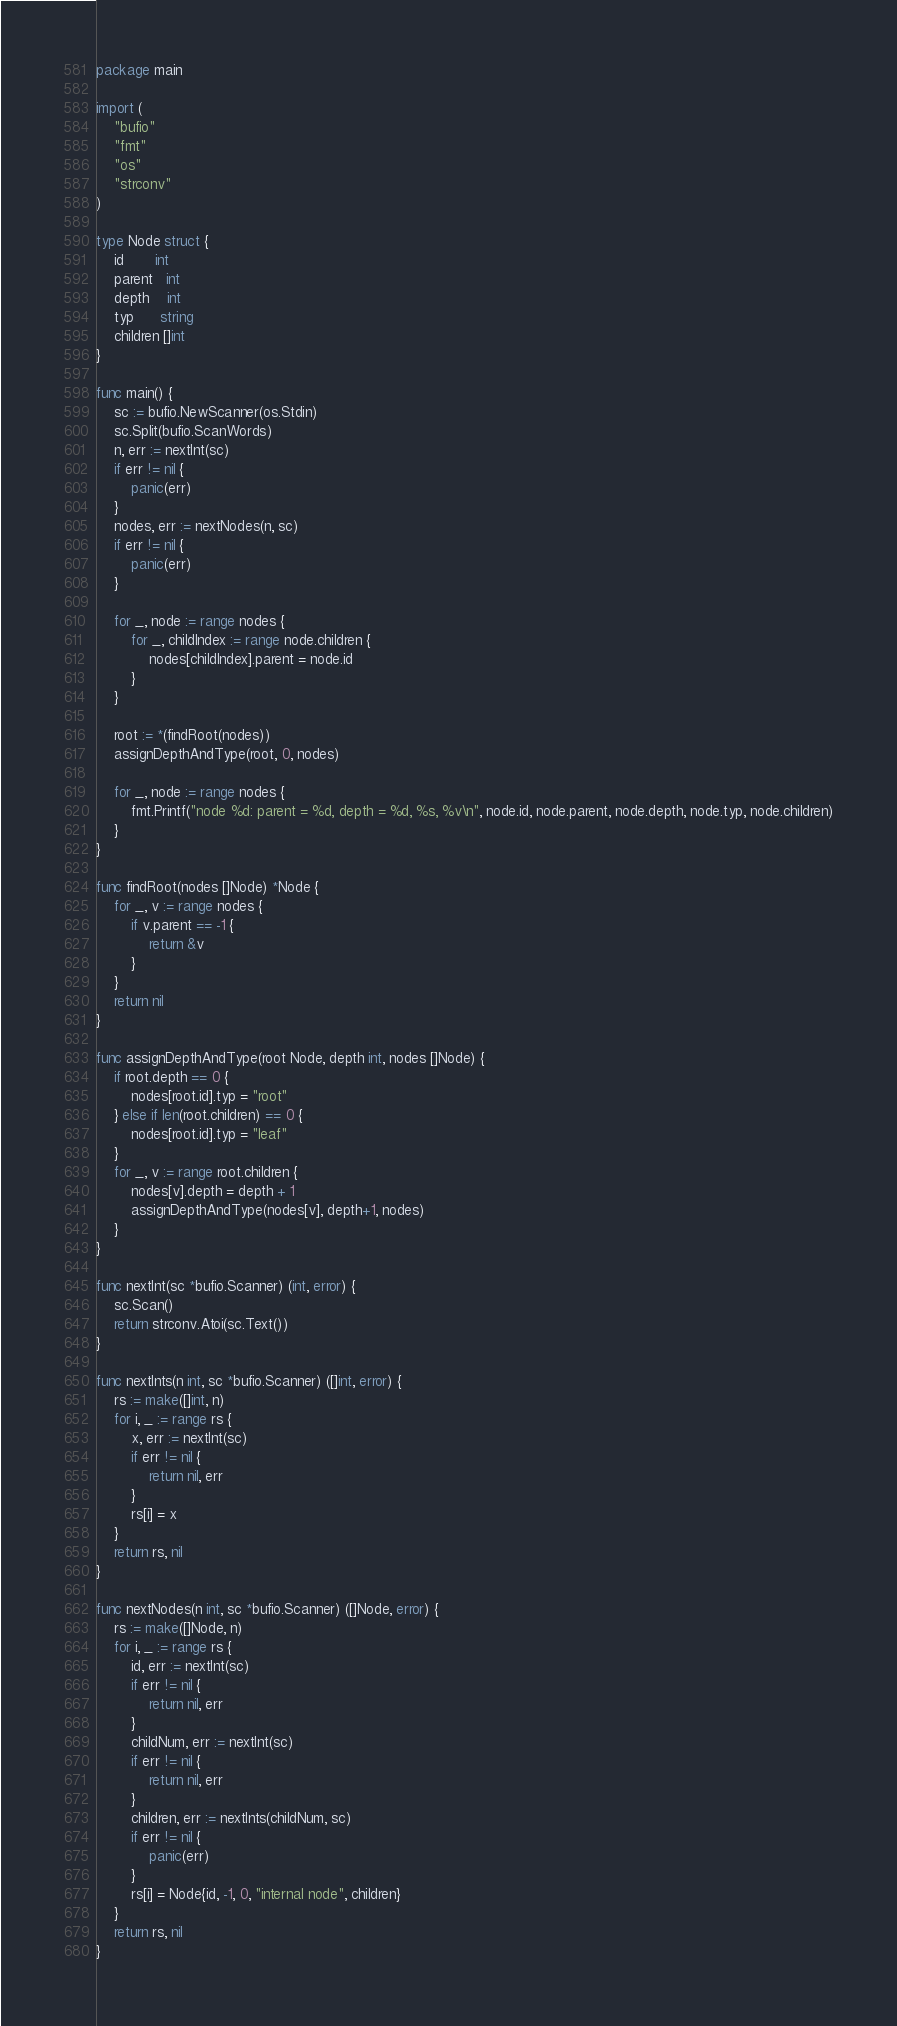Convert code to text. <code><loc_0><loc_0><loc_500><loc_500><_Go_>package main

import (
	"bufio"
	"fmt"
	"os"
	"strconv"
)

type Node struct {
	id       int
	parent   int
	depth    int
	typ      string
	children []int
}

func main() {
	sc := bufio.NewScanner(os.Stdin)
	sc.Split(bufio.ScanWords)
	n, err := nextInt(sc)
	if err != nil {
		panic(err)
	}
	nodes, err := nextNodes(n, sc)
	if err != nil {
		panic(err)
	}

	for _, node := range nodes {
		for _, childIndex := range node.children {
			nodes[childIndex].parent = node.id
		}
	}

	root := *(findRoot(nodes))
	assignDepthAndType(root, 0, nodes)

	for _, node := range nodes {
		fmt.Printf("node %d: parent = %d, depth = %d, %s, %v\n", node.id, node.parent, node.depth, node.typ, node.children)
	}
}

func findRoot(nodes []Node) *Node {
	for _, v := range nodes {
		if v.parent == -1 {
			return &v
		}
	}
	return nil
}

func assignDepthAndType(root Node, depth int, nodes []Node) {
	if root.depth == 0 {
		nodes[root.id].typ = "root"
	} else if len(root.children) == 0 {
		nodes[root.id].typ = "leaf"
	}
	for _, v := range root.children {
		nodes[v].depth = depth + 1
		assignDepthAndType(nodes[v], depth+1, nodes)
	}
}

func nextInt(sc *bufio.Scanner) (int, error) {
	sc.Scan()
	return strconv.Atoi(sc.Text())
}

func nextInts(n int, sc *bufio.Scanner) ([]int, error) {
	rs := make([]int, n)
	for i, _ := range rs {
		x, err := nextInt(sc)
		if err != nil {
			return nil, err
		}
		rs[i] = x
	}
	return rs, nil
}

func nextNodes(n int, sc *bufio.Scanner) ([]Node, error) {
	rs := make([]Node, n)
	for i, _ := range rs {
		id, err := nextInt(sc)
		if err != nil {
			return nil, err
		}
		childNum, err := nextInt(sc)
		if err != nil {
			return nil, err
		}
		children, err := nextInts(childNum, sc)
		if err != nil {
			panic(err)
		}
		rs[i] = Node{id, -1, 0, "internal node", children}
	}
	return rs, nil
}

</code> 